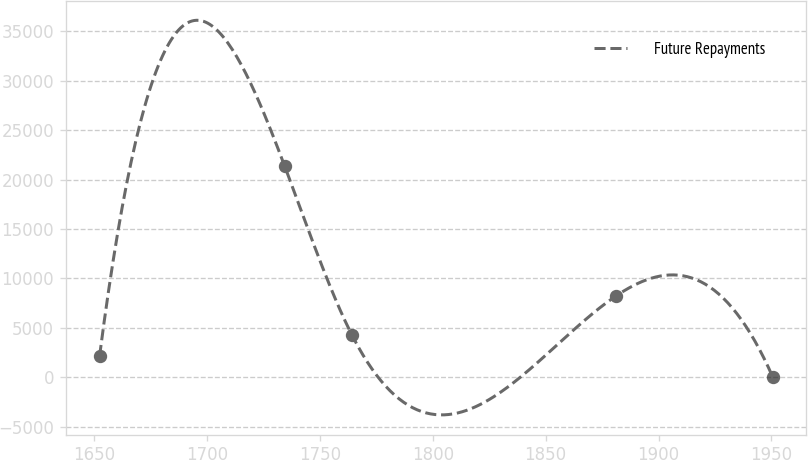Convert chart to OTSL. <chart><loc_0><loc_0><loc_500><loc_500><line_chart><ecel><fcel>Future Repayments<nl><fcel>1652.39<fcel>2147.45<nl><fcel>1734.34<fcel>21387.4<nl><fcel>1764.16<fcel>4285.22<nl><fcel>1881.18<fcel>8223.42<nl><fcel>1950.64<fcel>9.68<nl></chart> 